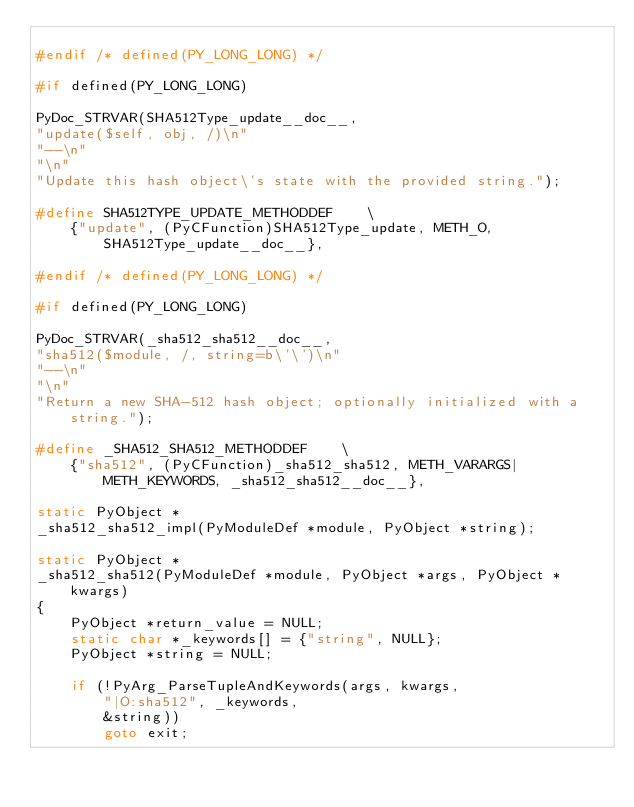Convert code to text. <code><loc_0><loc_0><loc_500><loc_500><_C_>
#endif /* defined(PY_LONG_LONG) */

#if defined(PY_LONG_LONG)

PyDoc_STRVAR(SHA512Type_update__doc__,
"update($self, obj, /)\n"
"--\n"
"\n"
"Update this hash object\'s state with the provided string.");

#define SHA512TYPE_UPDATE_METHODDEF    \
    {"update", (PyCFunction)SHA512Type_update, METH_O, SHA512Type_update__doc__},

#endif /* defined(PY_LONG_LONG) */

#if defined(PY_LONG_LONG)

PyDoc_STRVAR(_sha512_sha512__doc__,
"sha512($module, /, string=b\'\')\n"
"--\n"
"\n"
"Return a new SHA-512 hash object; optionally initialized with a string.");

#define _SHA512_SHA512_METHODDEF    \
    {"sha512", (PyCFunction)_sha512_sha512, METH_VARARGS|METH_KEYWORDS, _sha512_sha512__doc__},

static PyObject *
_sha512_sha512_impl(PyModuleDef *module, PyObject *string);

static PyObject *
_sha512_sha512(PyModuleDef *module, PyObject *args, PyObject *kwargs)
{
    PyObject *return_value = NULL;
    static char *_keywords[] = {"string", NULL};
    PyObject *string = NULL;

    if (!PyArg_ParseTupleAndKeywords(args, kwargs,
        "|O:sha512", _keywords,
        &string))
        goto exit;</code> 